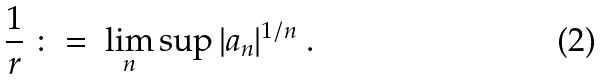Convert formula to latex. <formula><loc_0><loc_0><loc_500><loc_500>\frac { 1 } { r } \ \colon = \ \lim _ { n } \sup | a _ { n } | ^ { 1 / n } \ .</formula> 